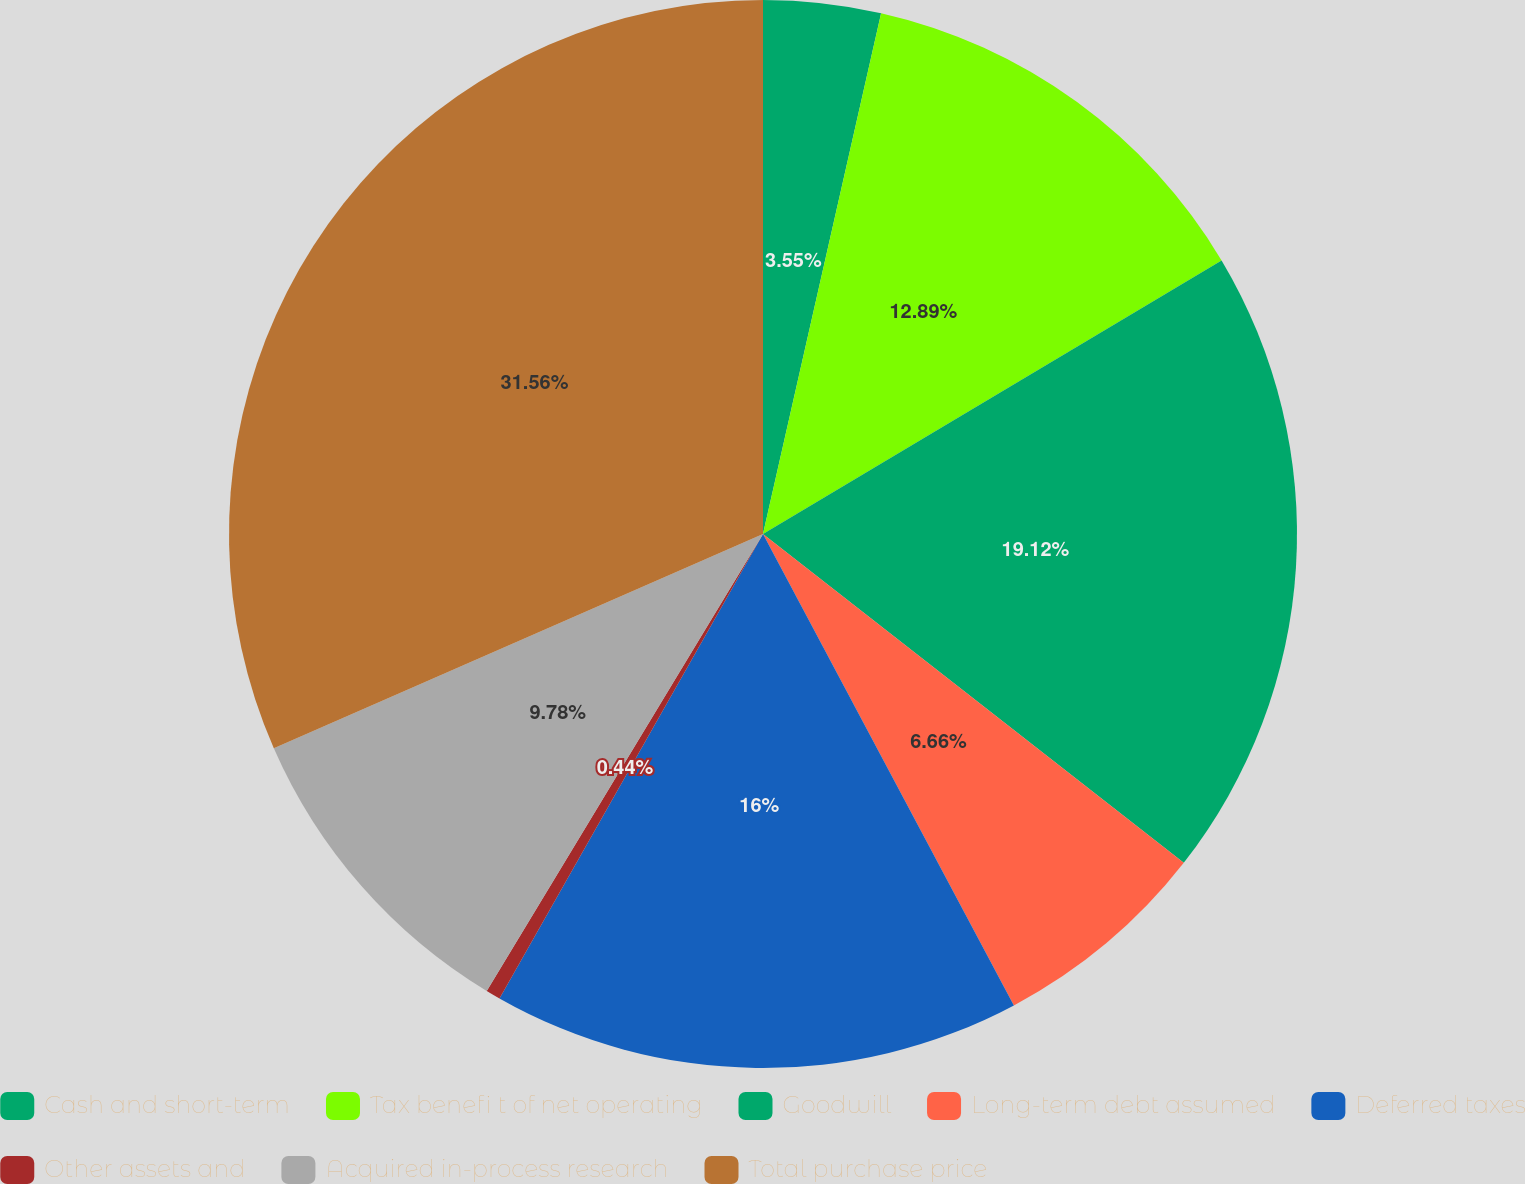Convert chart. <chart><loc_0><loc_0><loc_500><loc_500><pie_chart><fcel>Cash and short-term<fcel>Tax benefi t of net operating<fcel>Goodwill<fcel>Long-term debt assumed<fcel>Deferred taxes<fcel>Other assets and<fcel>Acquired in-process research<fcel>Total purchase price<nl><fcel>3.55%<fcel>12.89%<fcel>19.12%<fcel>6.66%<fcel>16.0%<fcel>0.44%<fcel>9.78%<fcel>31.57%<nl></chart> 